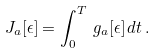Convert formula to latex. <formula><loc_0><loc_0><loc_500><loc_500>J _ { a } [ \epsilon ] = \int _ { 0 } ^ { T } \, g _ { a } [ \epsilon ] \, d t \, .</formula> 